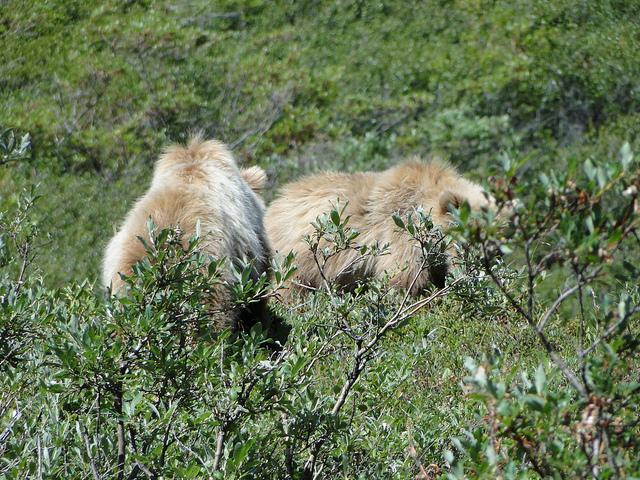What color are the flowers toward the middle/right?
Short answer required. White. How many animals are in the photo?
Give a very brief answer. 2. What type of animals are in the field?
Give a very brief answer. Bears. Why do these reptiles have fur?
Be succinct. There bears. Can you see the animals faces?
Write a very short answer. No. 